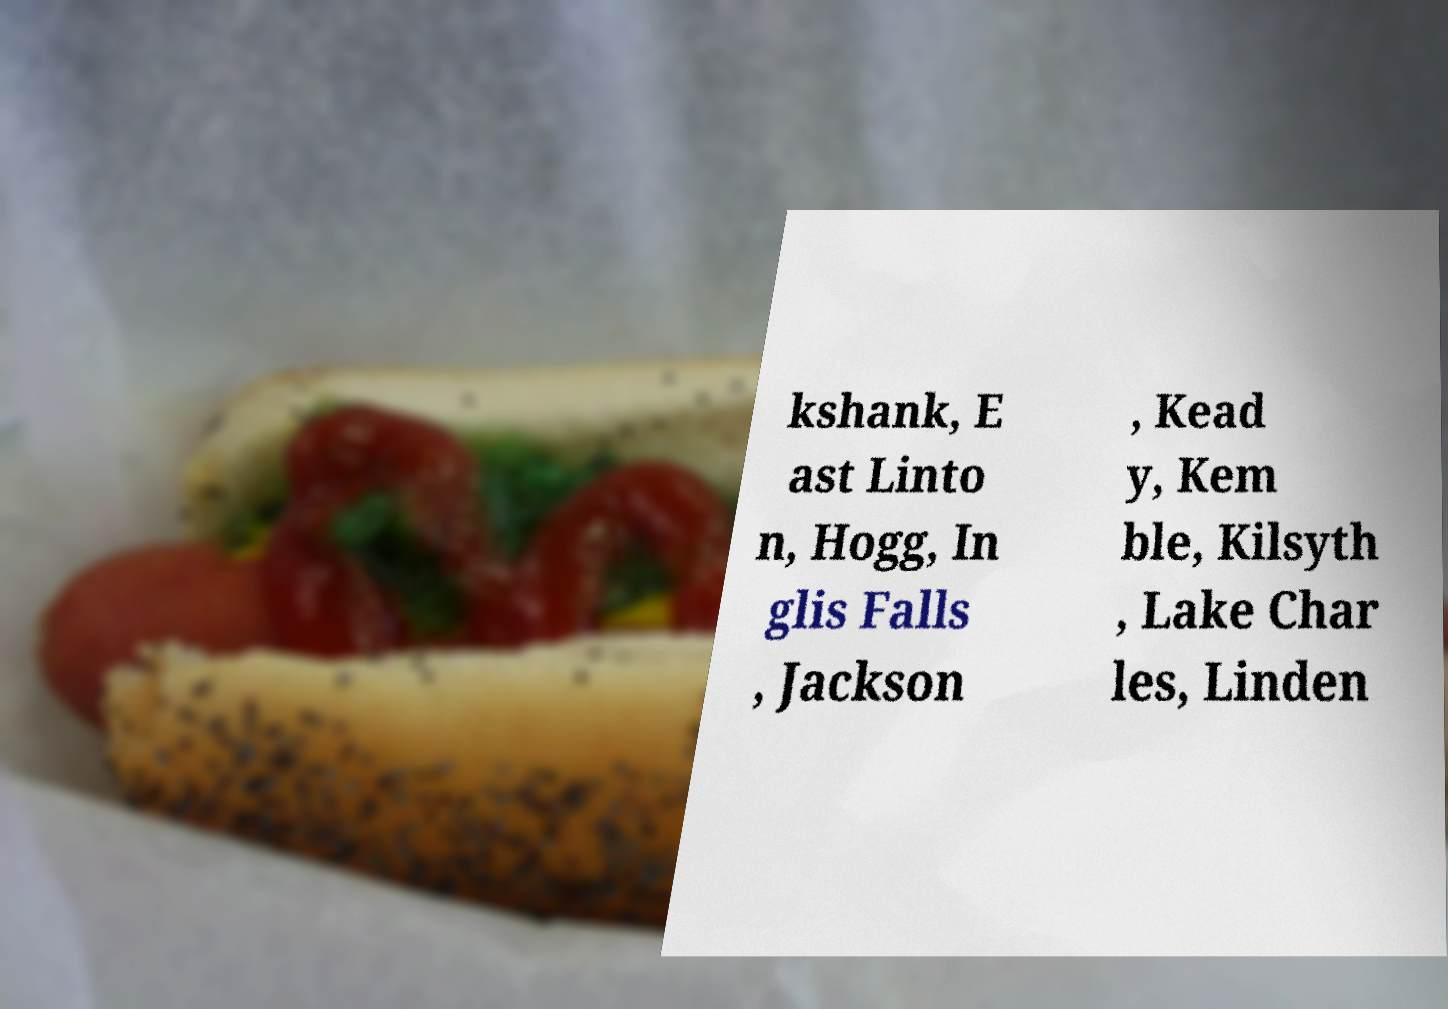Could you assist in decoding the text presented in this image and type it out clearly? kshank, E ast Linto n, Hogg, In glis Falls , Jackson , Kead y, Kem ble, Kilsyth , Lake Char les, Linden 